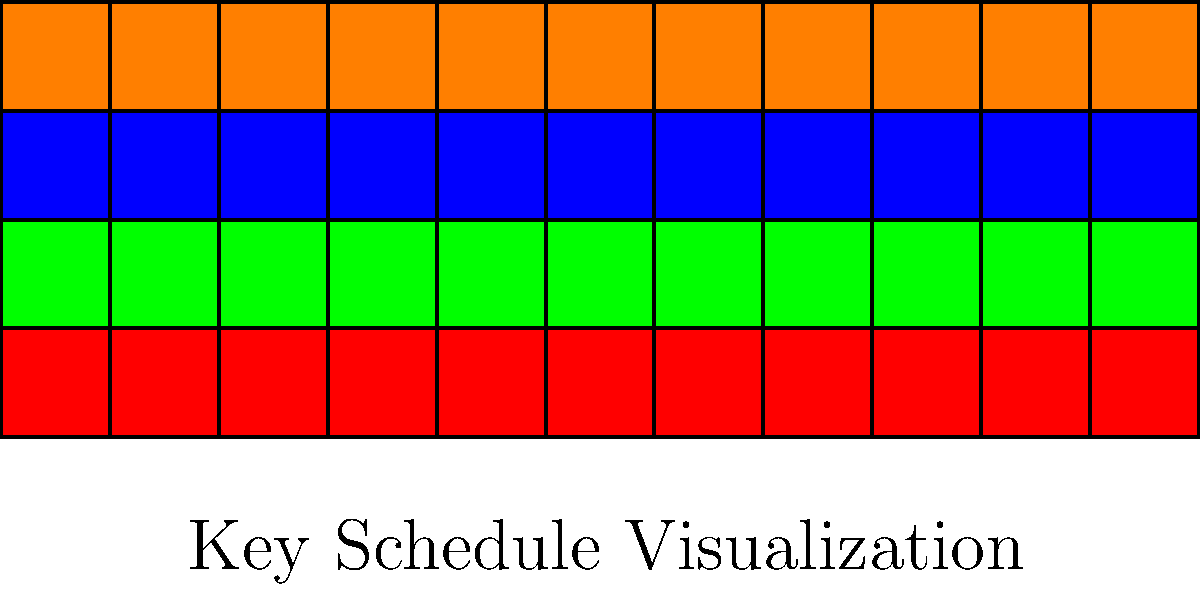Given the visual representation of a key schedule above, which cryptographic algorithm is most likely being depicted? To identify the cryptographic algorithm from the visual key schedule representation, we need to analyze the following characteristics:

1. Structure: The image shows a rectangular grid of colored boxes.
2. Number of rows: There are 4 rows in the grid.
3. Number of columns: There are 11 columns in the grid.
4. Color pattern: Each row has a consistent color throughout.

These characteristics are indicative of the AES (Advanced Encryption Standard) key schedule:

1. AES uses a key expansion routine to generate a series of round keys from the initial cipher key.
2. The 4 rows represent the 4 words (32 bits each) in each round key.
3. The 11 columns correspond to the 11 round keys used in AES-128 (10 rounds plus the initial round key).
4. The consistent color per row visualizes how each word in the key schedule is derived from the previous round's corresponding word.

Other common encryption algorithms like DES or 3DES have different key schedule structures, and asymmetric algorithms like RSA don't use such key schedules at all.

Therefore, based on the 4x11 grid structure and the color pattern, this visual representation is most consistent with the AES key schedule.
Answer: AES (Advanced Encryption Standard) 